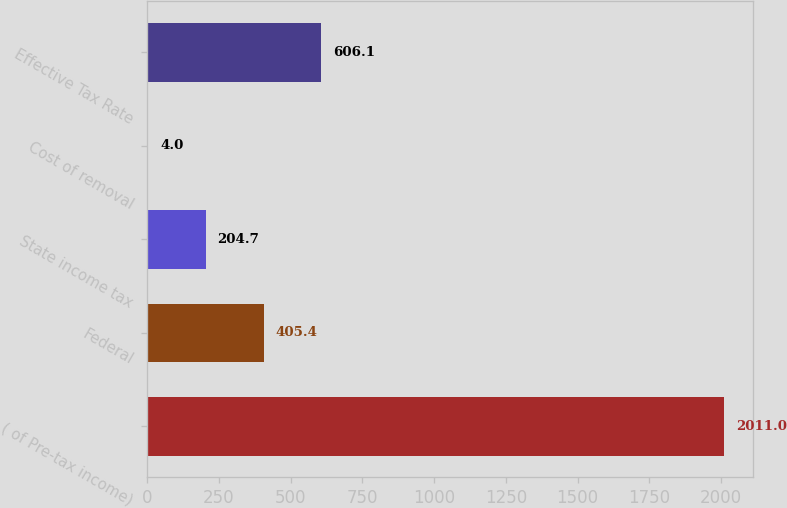Convert chart. <chart><loc_0><loc_0><loc_500><loc_500><bar_chart><fcel>( of Pre-tax income)<fcel>Federal<fcel>State income tax<fcel>Cost of removal<fcel>Effective Tax Rate<nl><fcel>2011<fcel>405.4<fcel>204.7<fcel>4<fcel>606.1<nl></chart> 